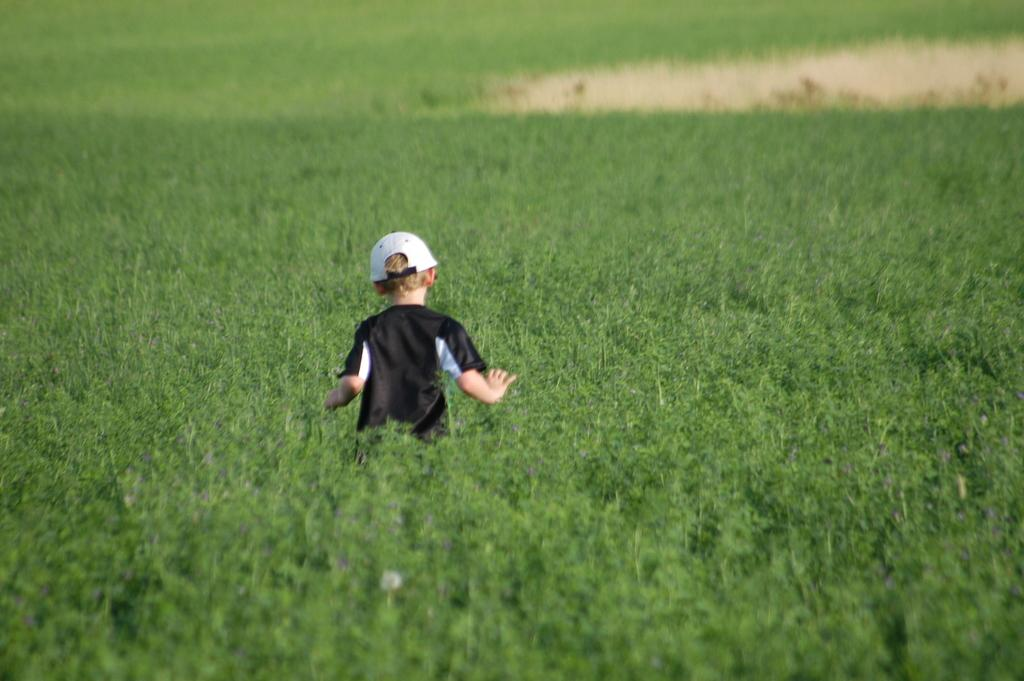Who is the main subject in the image? There is a boy in the image. What is the boy wearing on his head? The boy is wearing a white cap. What type of shirt is the boy wearing? The boy is wearing a black t-shirt. What is the color of the background in the image? The boy is in a green color field. What type of produce can be seen growing in the background of the image? There is no produce visible in the image; the background is a green color field. 